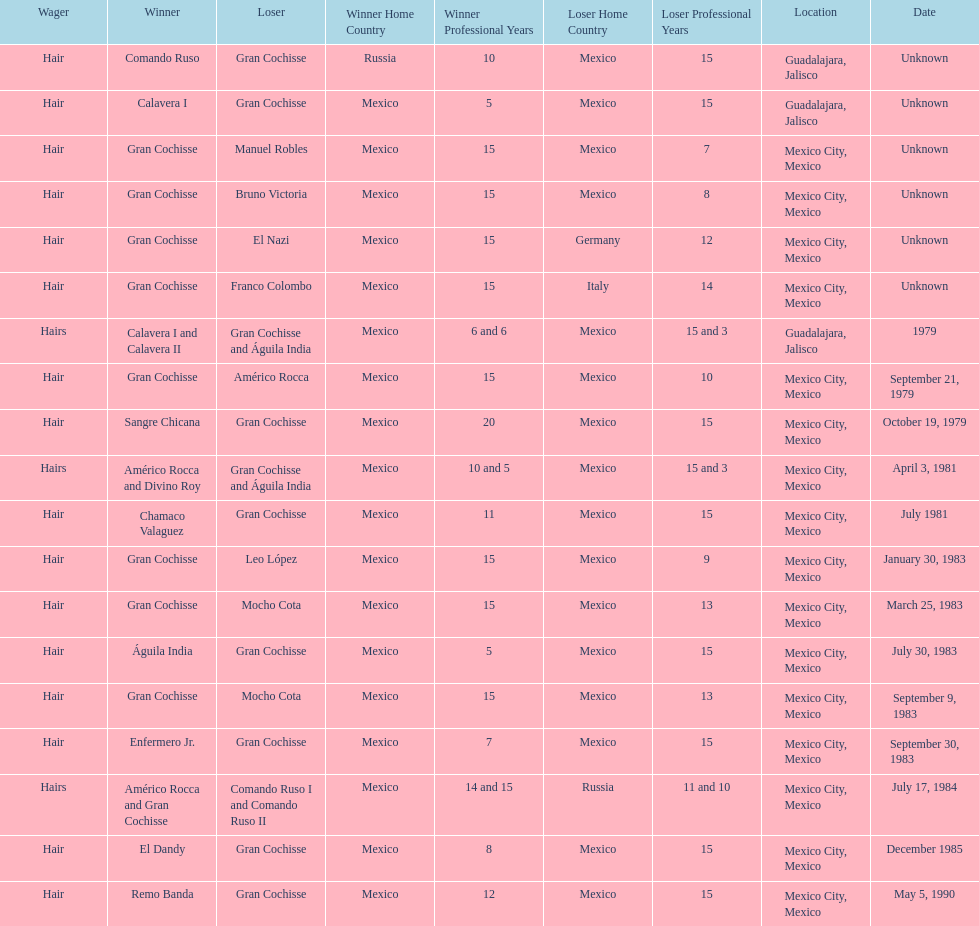How many games more than chamaco valaguez did sangre chicana win? 0. 